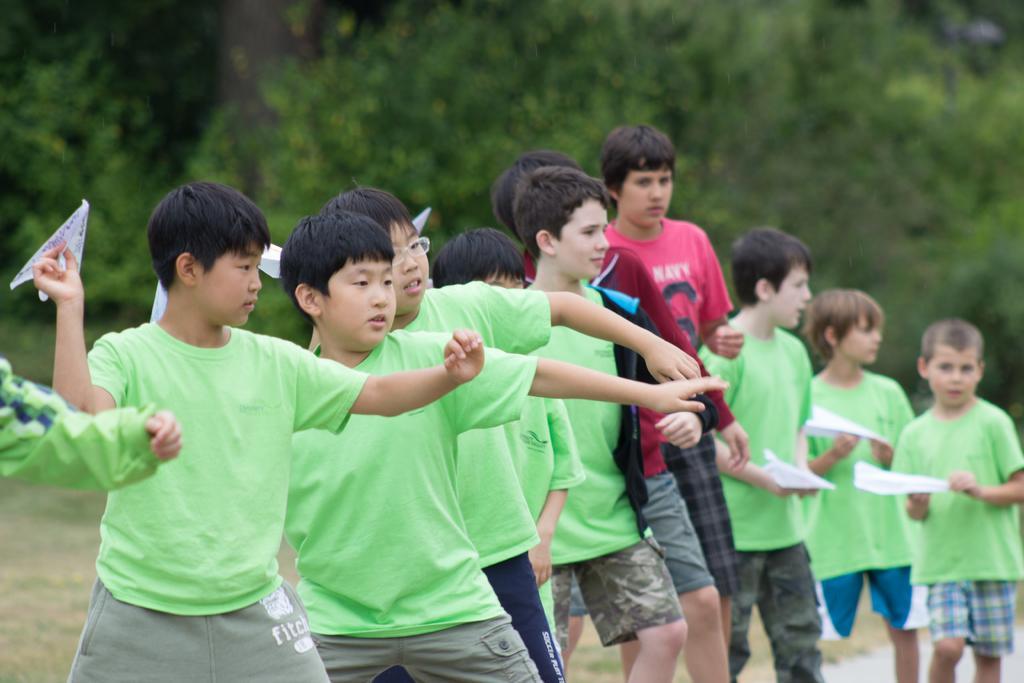Could you give a brief overview of what you see in this image? In this image in the foreground few boys visible, some of them holding paper aeroplane, in the background there are few trees. 